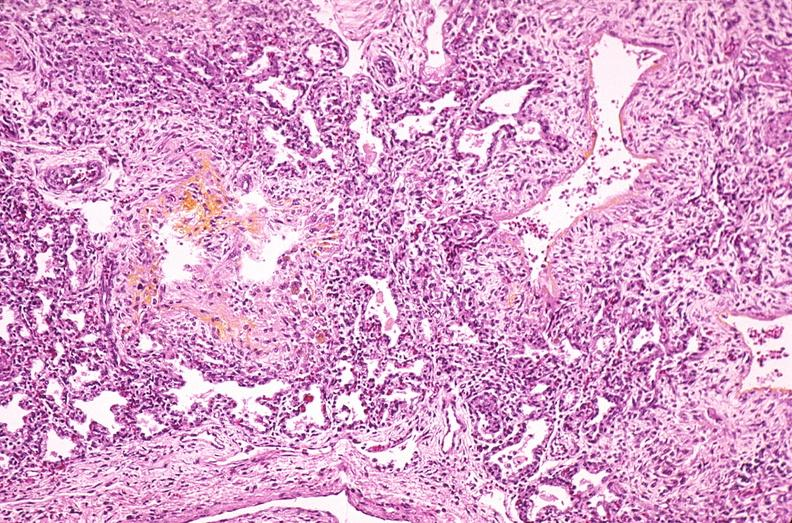what does this image show?
Answer the question using a single word or phrase. Lung 